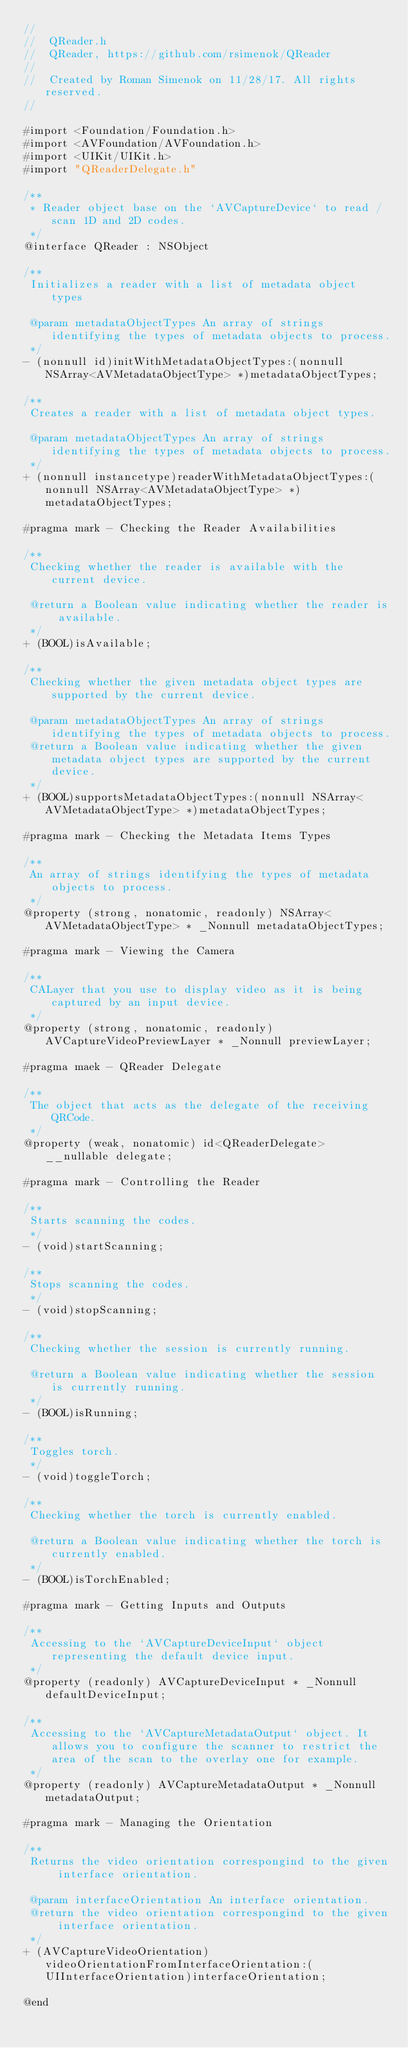Convert code to text. <code><loc_0><loc_0><loc_500><loc_500><_C_>//
//  QReader.h
//  QReader, https://github.com/rsimenok/QReader
//
//  Created by Roman Simenok on 11/28/17. All rights reserved.
//

#import <Foundation/Foundation.h>
#import <AVFoundation/AVFoundation.h>
#import <UIKit/UIKit.h>
#import "QReaderDelegate.h"

/**
 * Reader object base on the `AVCaptureDevice` to read / scan 1D and 2D codes.
 */
@interface QReader : NSObject

/**
 Initializes a reader with a list of metadata object types

 @param metadataObjectTypes An array of strings identifying the types of metadata objects to process.
 */
- (nonnull id)initWithMetadataObjectTypes:(nonnull NSArray<AVMetadataObjectType> *)metadataObjectTypes;

/**
 Creates a reader with a list of metadata object types.

 @param metadataObjectTypes An array of strings identifying the types of metadata objects to process.
 */
+ (nonnull instancetype)readerWithMetadataObjectTypes:(nonnull NSArray<AVMetadataObjectType> *)metadataObjectTypes;

#pragma mark - Checking the Reader Availabilities

/**
 Checking whether the reader is available with the current device.

 @return a Boolean value indicating whether the reader is available.
 */
+ (BOOL)isAvailable;

/**
 Checking whether the given metadata object types are supported by the current device.

 @param metadataObjectTypes An array of strings identifying the types of metadata objects to process.
 @return a Boolean value indicating whether the given metadata object types are supported by the current device.
 */
+ (BOOL)supportsMetadataObjectTypes:(nonnull NSArray<AVMetadataObjectType> *)metadataObjectTypes;

#pragma mark - Checking the Metadata Items Types

/**
 An array of strings identifying the types of metadata objects to process.
 */
@property (strong, nonatomic, readonly) NSArray<AVMetadataObjectType> * _Nonnull metadataObjectTypes;

#pragma mark - Viewing the Camera

/**
 CALayer that you use to display video as it is being captured by an input device.
 */
@property (strong, nonatomic, readonly) AVCaptureVideoPreviewLayer * _Nonnull previewLayer;

#pragma maek - QReader Delegate

/**
 The object that acts as the delegate of the receiving QRCode.
 */
@property (weak, nonatomic) id<QReaderDelegate> __nullable delegate;

#pragma mark - Controlling the Reader

/**
 Starts scanning the codes.
 */
- (void)startScanning;

/**
 Stops scanning the codes.
 */
- (void)stopScanning;

/**
 Checking whether the session is currently running.

 @return a Boolean value indicating whether the session is currently running.
 */
- (BOOL)isRunning;

/**
 Toggles torch.
 */
- (void)toggleTorch;

/**
 Checking whether the torch is currently enabled.

 @return a Boolean value indicating whether the torch is currently enabled.
 */
- (BOOL)isTorchEnabled;

#pragma mark - Getting Inputs and Outputs

/**
 Accessing to the `AVCaptureDeviceInput` object representing the default device input.
 */
@property (readonly) AVCaptureDeviceInput * _Nonnull defaultDeviceInput;

/**
 Accessing to the `AVCaptureMetadataOutput` object. It allows you to configure the scanner to restrict the area of the scan to the overlay one for example.
 */
@property (readonly) AVCaptureMetadataOutput * _Nonnull metadataOutput;

#pragma mark - Managing the Orientation

/**
 Returns the video orientation correspongind to the given interface orientation.
 
 @param interfaceOrientation An interface orientation.
 @return the video orientation correspongind to the given interface orientation.
 */
+ (AVCaptureVideoOrientation)videoOrientationFromInterfaceOrientation:(UIInterfaceOrientation)interfaceOrientation;

@end
</code> 